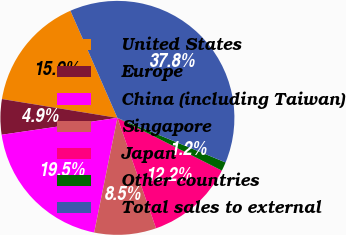Convert chart. <chart><loc_0><loc_0><loc_500><loc_500><pie_chart><fcel>United States<fcel>Europe<fcel>China (including Taiwan)<fcel>Singapore<fcel>Japan<fcel>Other countries<fcel>Total sales to external<nl><fcel>15.85%<fcel>4.88%<fcel>19.51%<fcel>8.54%<fcel>12.2%<fcel>1.22%<fcel>37.8%<nl></chart> 